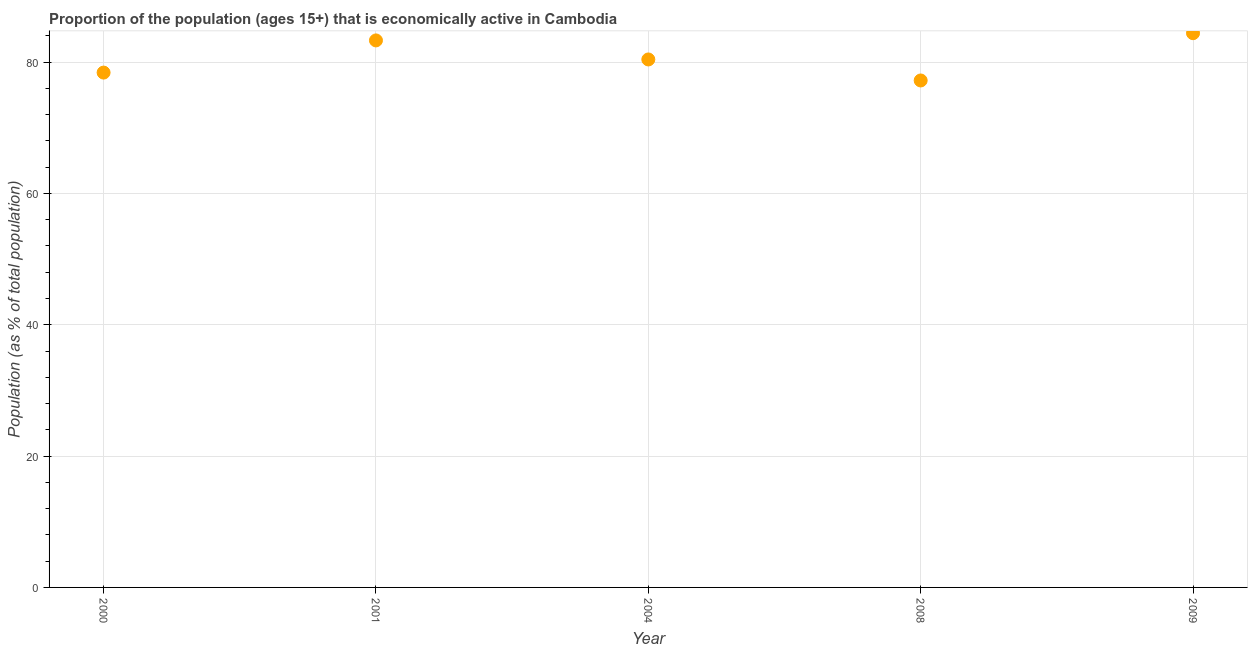What is the percentage of economically active population in 2009?
Provide a short and direct response. 84.4. Across all years, what is the maximum percentage of economically active population?
Give a very brief answer. 84.4. Across all years, what is the minimum percentage of economically active population?
Your response must be concise. 77.2. In which year was the percentage of economically active population minimum?
Offer a very short reply. 2008. What is the sum of the percentage of economically active population?
Keep it short and to the point. 403.7. What is the average percentage of economically active population per year?
Offer a terse response. 80.74. What is the median percentage of economically active population?
Your response must be concise. 80.4. In how many years, is the percentage of economically active population greater than 24 %?
Make the answer very short. 5. Do a majority of the years between 2008 and 2001 (inclusive) have percentage of economically active population greater than 64 %?
Your response must be concise. No. What is the ratio of the percentage of economically active population in 2001 to that in 2004?
Provide a short and direct response. 1.04. Is the percentage of economically active population in 2001 less than that in 2009?
Your answer should be compact. Yes. Is the difference between the percentage of economically active population in 2000 and 2009 greater than the difference between any two years?
Your answer should be very brief. No. What is the difference between the highest and the second highest percentage of economically active population?
Keep it short and to the point. 1.1. Is the sum of the percentage of economically active population in 2000 and 2004 greater than the maximum percentage of economically active population across all years?
Ensure brevity in your answer.  Yes. What is the difference between the highest and the lowest percentage of economically active population?
Make the answer very short. 7.2. How many dotlines are there?
Make the answer very short. 1. Does the graph contain any zero values?
Offer a terse response. No. What is the title of the graph?
Give a very brief answer. Proportion of the population (ages 15+) that is economically active in Cambodia. What is the label or title of the X-axis?
Provide a succinct answer. Year. What is the label or title of the Y-axis?
Provide a short and direct response. Population (as % of total population). What is the Population (as % of total population) in 2000?
Make the answer very short. 78.4. What is the Population (as % of total population) in 2001?
Offer a very short reply. 83.3. What is the Population (as % of total population) in 2004?
Your answer should be very brief. 80.4. What is the Population (as % of total population) in 2008?
Offer a terse response. 77.2. What is the Population (as % of total population) in 2009?
Offer a terse response. 84.4. What is the difference between the Population (as % of total population) in 2000 and 2001?
Ensure brevity in your answer.  -4.9. What is the difference between the Population (as % of total population) in 2000 and 2004?
Make the answer very short. -2. What is the difference between the Population (as % of total population) in 2000 and 2008?
Make the answer very short. 1.2. What is the difference between the Population (as % of total population) in 2000 and 2009?
Make the answer very short. -6. What is the difference between the Population (as % of total population) in 2001 and 2008?
Provide a succinct answer. 6.1. What is the ratio of the Population (as % of total population) in 2000 to that in 2001?
Your answer should be very brief. 0.94. What is the ratio of the Population (as % of total population) in 2000 to that in 2009?
Keep it short and to the point. 0.93. What is the ratio of the Population (as % of total population) in 2001 to that in 2004?
Keep it short and to the point. 1.04. What is the ratio of the Population (as % of total population) in 2001 to that in 2008?
Give a very brief answer. 1.08. What is the ratio of the Population (as % of total population) in 2004 to that in 2008?
Keep it short and to the point. 1.04. What is the ratio of the Population (as % of total population) in 2004 to that in 2009?
Give a very brief answer. 0.95. What is the ratio of the Population (as % of total population) in 2008 to that in 2009?
Offer a terse response. 0.92. 